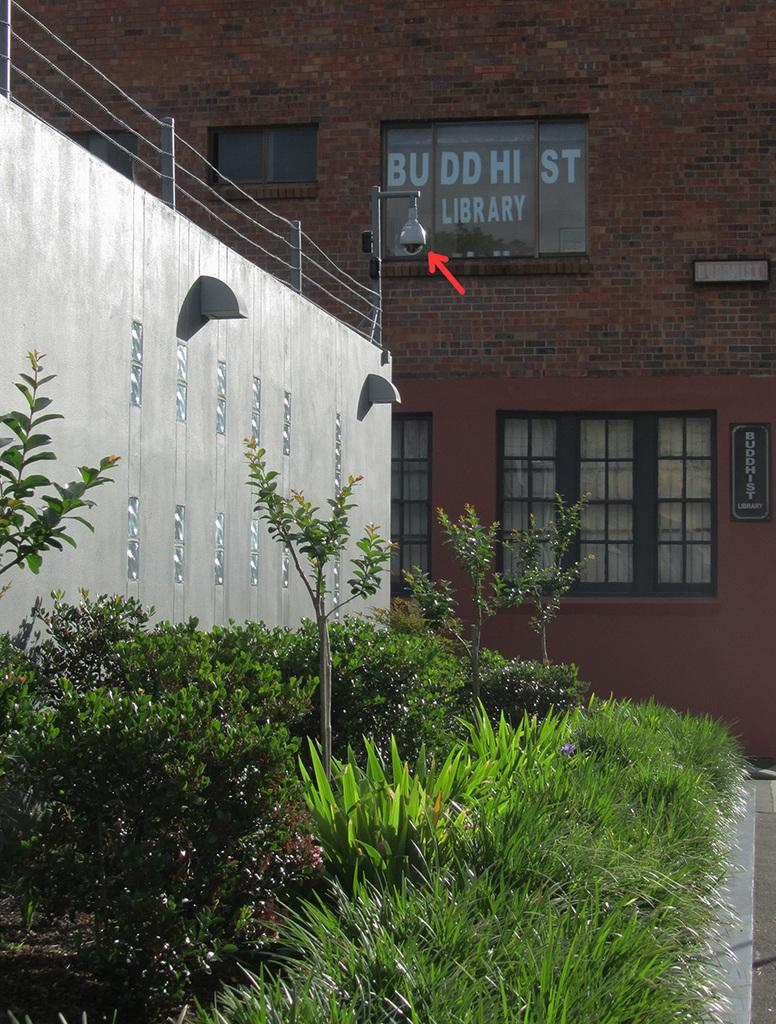What type of structure is visible in the image? There is a building in the image. What can be seen on the boards in the image? There are boards with text in the image. What architectural feature is present in the image? There are windows in the image. What safety feature is visible in the image? There are railings in the image. What source of illumination is present in the image? There is a light in the image. What type of vegetation is present in the image? There are plants in the image. What is at the bottom of the image? There is a road at the bottom of the image. How many books can be seen on the railings in the image? There are no books present on the railings in the image. What type of hearing aid is visible in the image? There is: There is no hearing aid present in the image. 